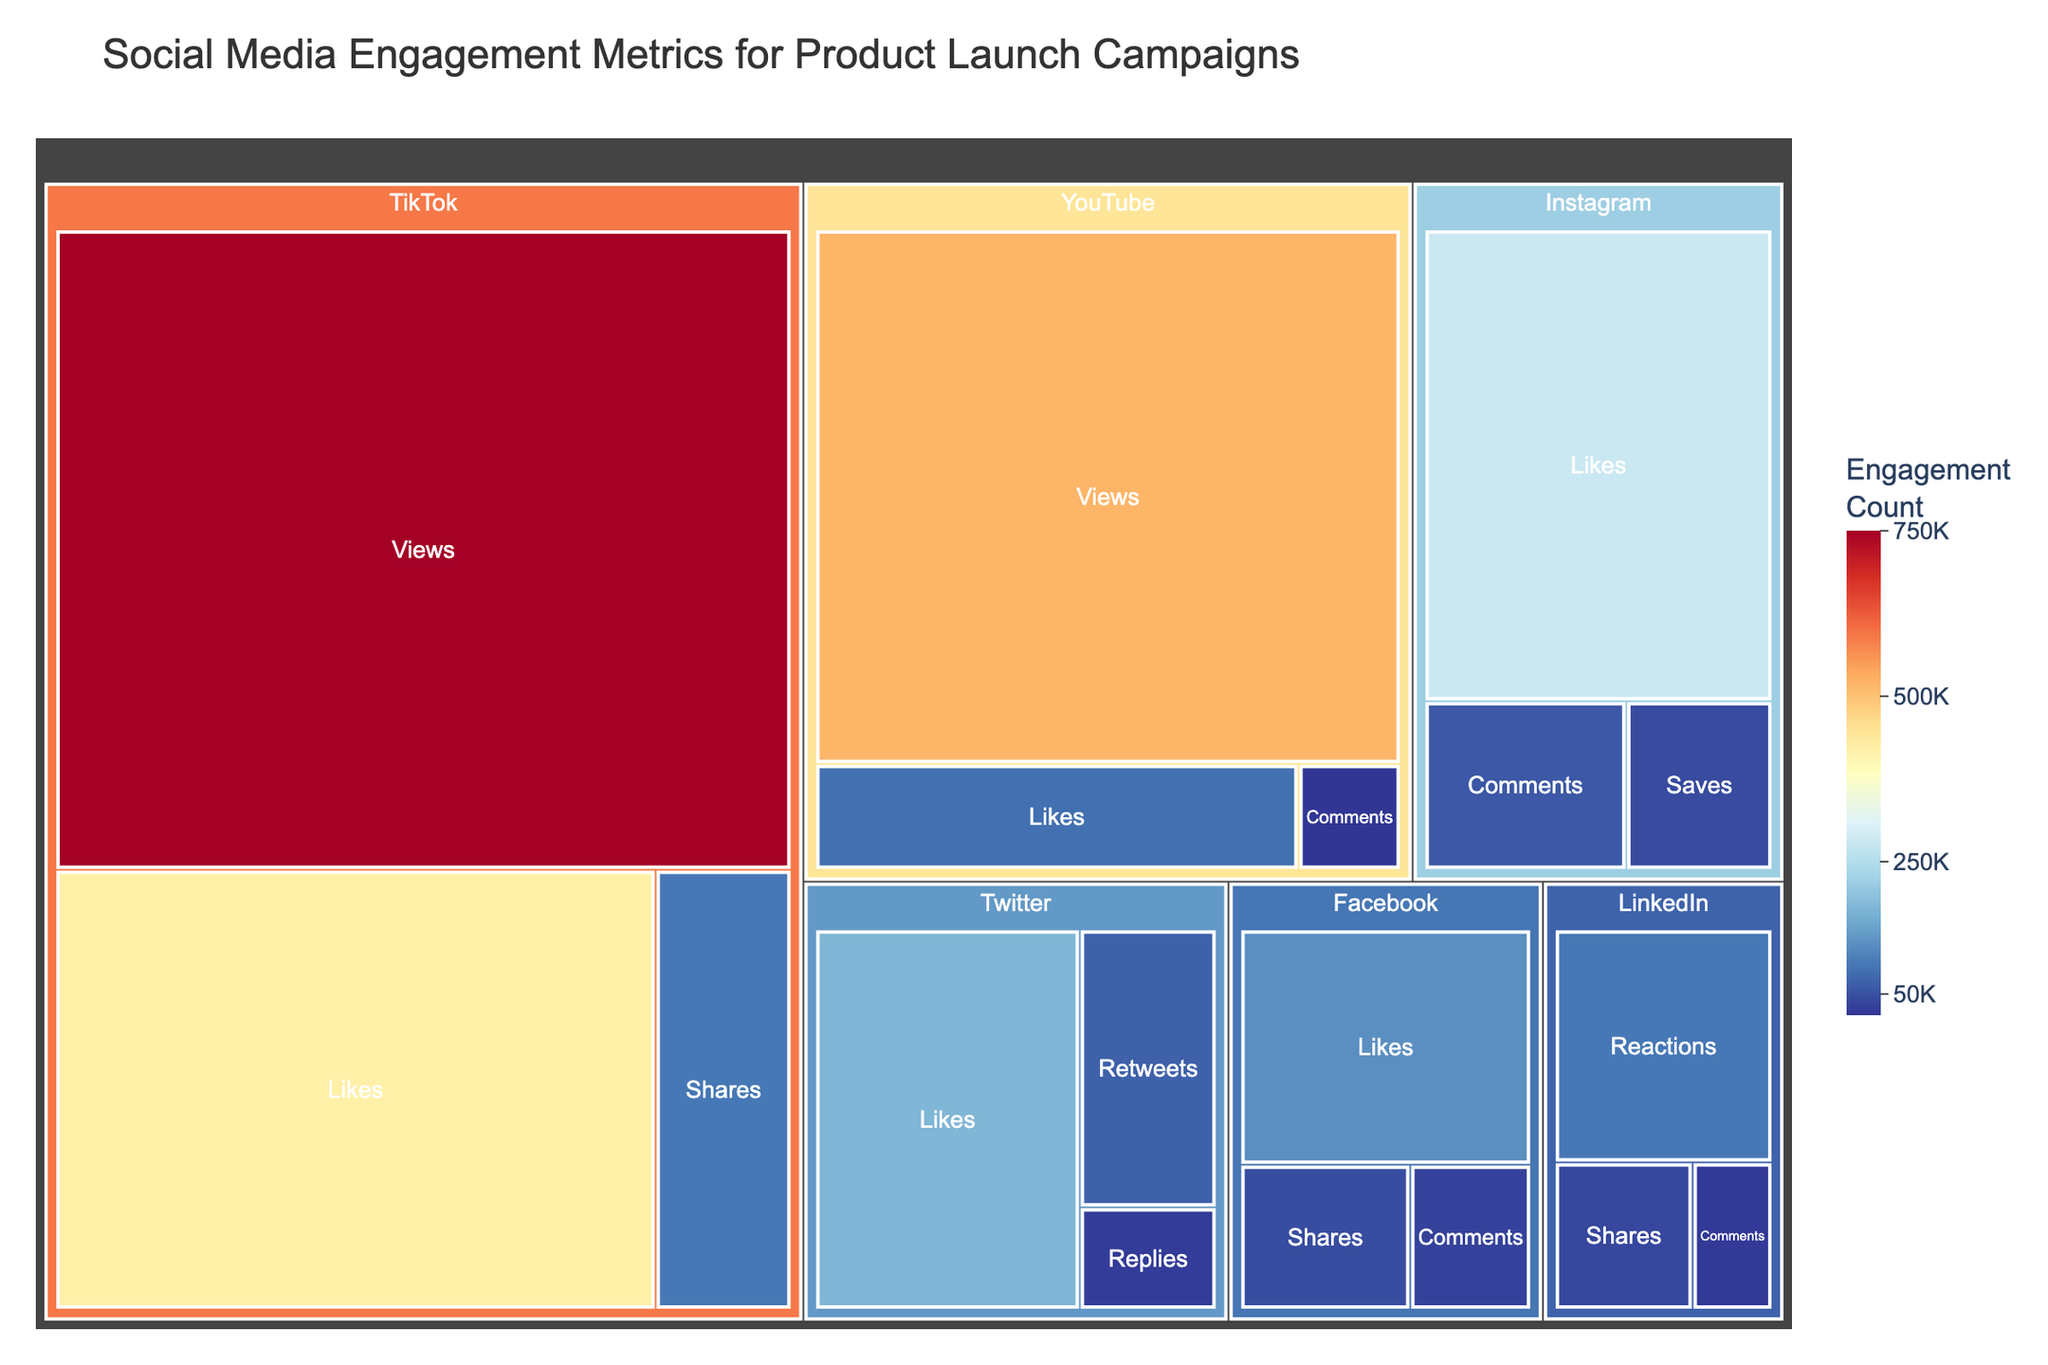What is the title of the treemap? The title is usually displayed prominently at the top of the figure. The treemap's title clearly indicates the overall subject and purpose of the visualization.
Answer: Social Media Engagement Metrics for Product Launch Campaigns Which platform has the highest value for any engagement metric? Looking at the values provided in the treemap, TikTok shows the highest engagement for any metric with 'Views' at 750,000.
Answer: TikTok What is the total number of likes across all platforms? To find the total number of likes, sum the values associated with 'Likes' for each platform: Facebook (125,000) + Instagram (280,000) + Twitter (180,000) + YouTube (85,000) + TikTok (420,000).
Answer: 1,090,000 Which platform in the treemap shows the lowest engagement for comments? By examining the 'Comments' values for all platforms, LinkedIn has the lowest engagement for comments with a value of 22,000.
Answer: LinkedIn Compare the views on TikTok and YouTube. Which platform has more views and by how much? Compare the values for views: TikTok (750,000) and YouTube (520,000). The difference is calculated by subtracting YouTube's views from TikTok's views: 750,000 - 520,000.
Answer: TikTok, 230,000 What are the types of engagement metrics shown for Facebook? The treemap lists different engagement metrics under each platform. For Facebook, the metrics are 'Likes', 'Shares', and 'Comments'.
Answer: Likes, Shares, Comments How many more comments are there on Instagram compared to YouTube? Compare the comments by subtracting the number of YouTube comments from Instagram comments: 58,000 (Instagram) - 18,000 (YouTube).
Answer: 40,000 What is the combined value of shares on Facebook and LinkedIn? Sum the values of shares: Facebook (45,000) + LinkedIn (38,000).
Answer: 83,000 Identify the platform with the second-highest number of likes. First, determine the number of likes on each platform: TikTok (420,000), Instagram (280,000), Twitter (180,000), Facebook (125,000), YouTube (85,000). Instagram has the second-highest number of likes.
Answer: Instagram Which platform(s) have engagement metrics involving 'Reactions' and 'Saves'? By analyzing the types of engagement metrics in the treemap, LinkedIn has 'Reactions', and Instagram has 'Saves'.
Answer: LinkedIn (Reactions) and Instagram (Saves) 